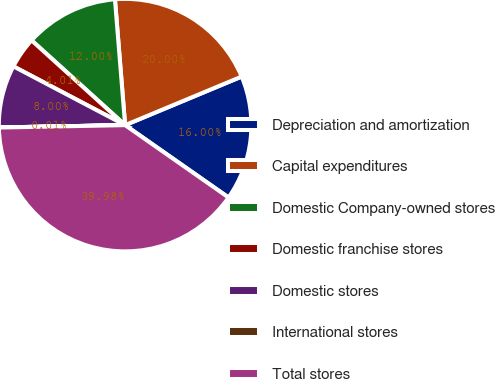Convert chart to OTSL. <chart><loc_0><loc_0><loc_500><loc_500><pie_chart><fcel>Depreciation and amortization<fcel>Capital expenditures<fcel>Domestic Company-owned stores<fcel>Domestic franchise stores<fcel>Domestic stores<fcel>International stores<fcel>Total stores<nl><fcel>16.0%<fcel>20.0%<fcel>12.0%<fcel>4.01%<fcel>8.0%<fcel>0.01%<fcel>39.98%<nl></chart> 